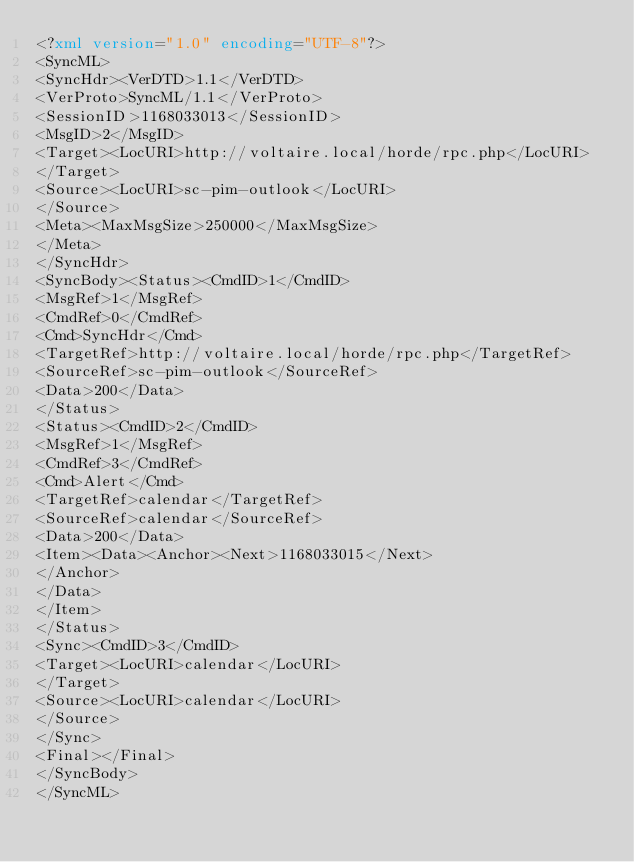<code> <loc_0><loc_0><loc_500><loc_500><_XML_><?xml version="1.0" encoding="UTF-8"?>
<SyncML>
<SyncHdr><VerDTD>1.1</VerDTD>
<VerProto>SyncML/1.1</VerProto>
<SessionID>1168033013</SessionID>
<MsgID>2</MsgID>
<Target><LocURI>http://voltaire.local/horde/rpc.php</LocURI>
</Target>
<Source><LocURI>sc-pim-outlook</LocURI>
</Source>
<Meta><MaxMsgSize>250000</MaxMsgSize>
</Meta>
</SyncHdr>
<SyncBody><Status><CmdID>1</CmdID>
<MsgRef>1</MsgRef>
<CmdRef>0</CmdRef>
<Cmd>SyncHdr</Cmd>
<TargetRef>http://voltaire.local/horde/rpc.php</TargetRef>
<SourceRef>sc-pim-outlook</SourceRef>
<Data>200</Data>
</Status>
<Status><CmdID>2</CmdID>
<MsgRef>1</MsgRef>
<CmdRef>3</CmdRef>
<Cmd>Alert</Cmd>
<TargetRef>calendar</TargetRef>
<SourceRef>calendar</SourceRef>
<Data>200</Data>
<Item><Data><Anchor><Next>1168033015</Next>
</Anchor>
</Data>
</Item>
</Status>
<Sync><CmdID>3</CmdID>
<Target><LocURI>calendar</LocURI>
</Target>
<Source><LocURI>calendar</LocURI>
</Source>
</Sync>
<Final></Final>
</SyncBody>
</SyncML></code> 